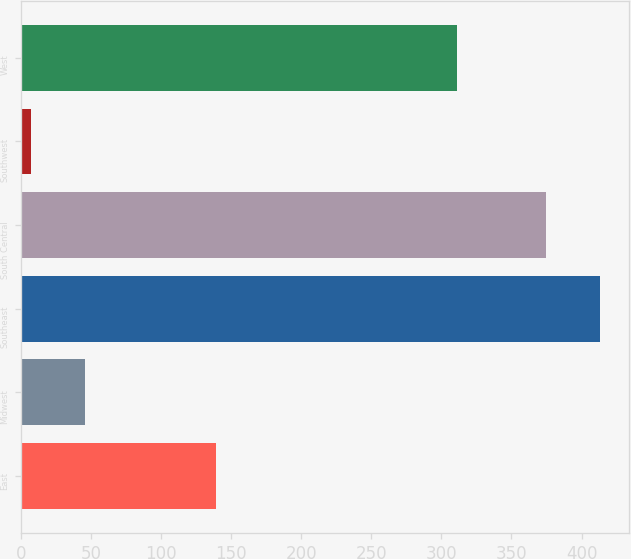Convert chart. <chart><loc_0><loc_0><loc_500><loc_500><bar_chart><fcel>East<fcel>Midwest<fcel>Southeast<fcel>South Central<fcel>Southwest<fcel>West<nl><fcel>138.7<fcel>45.41<fcel>412.91<fcel>374.8<fcel>7.3<fcel>310.9<nl></chart> 